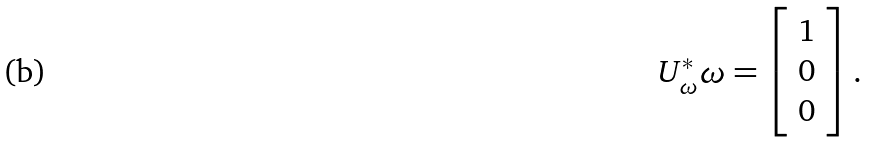Convert formula to latex. <formula><loc_0><loc_0><loc_500><loc_500>U _ { \omega } ^ { * } \omega = \left [ \begin{array} { c c } 1 \\ 0 \\ 0 \end{array} \right ] .</formula> 